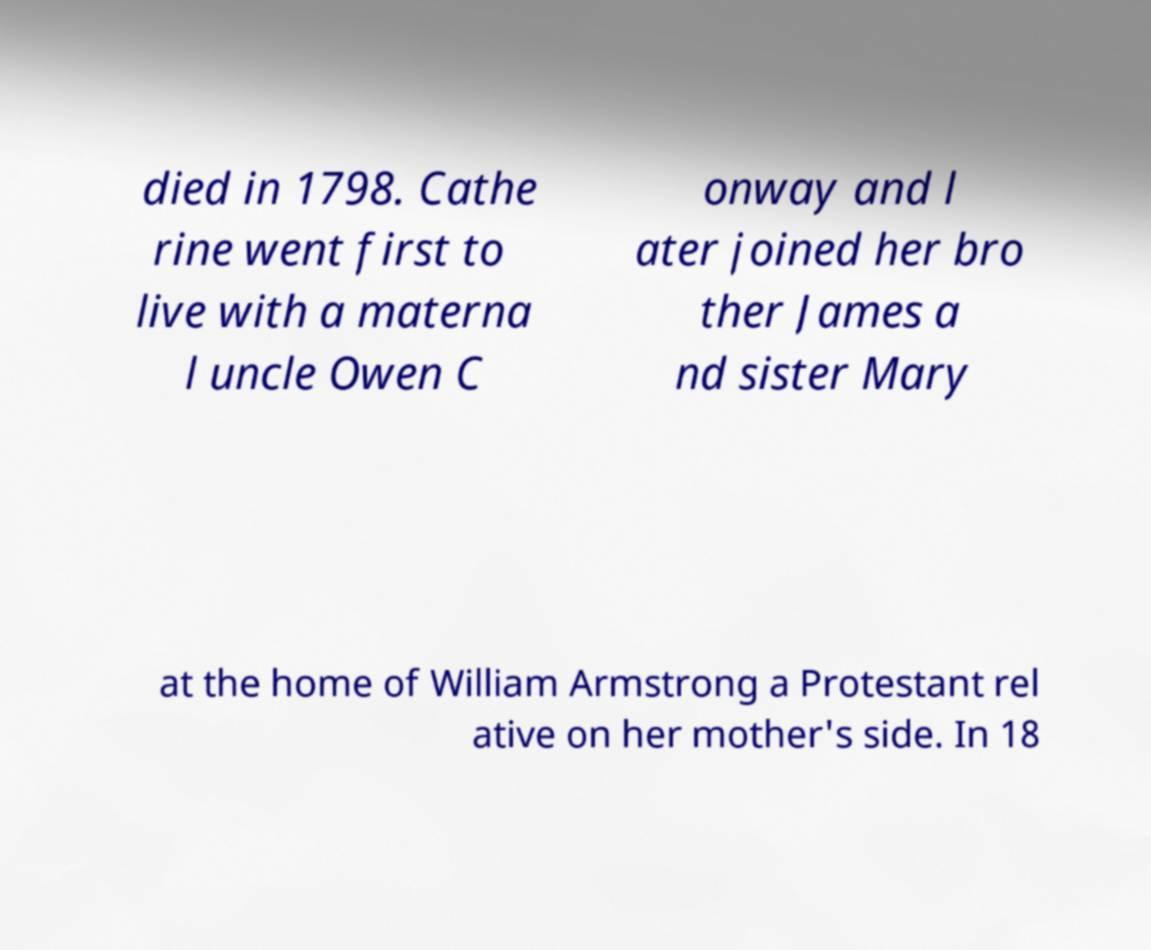Could you assist in decoding the text presented in this image and type it out clearly? died in 1798. Cathe rine went first to live with a materna l uncle Owen C onway and l ater joined her bro ther James a nd sister Mary at the home of William Armstrong a Protestant rel ative on her mother's side. In 18 